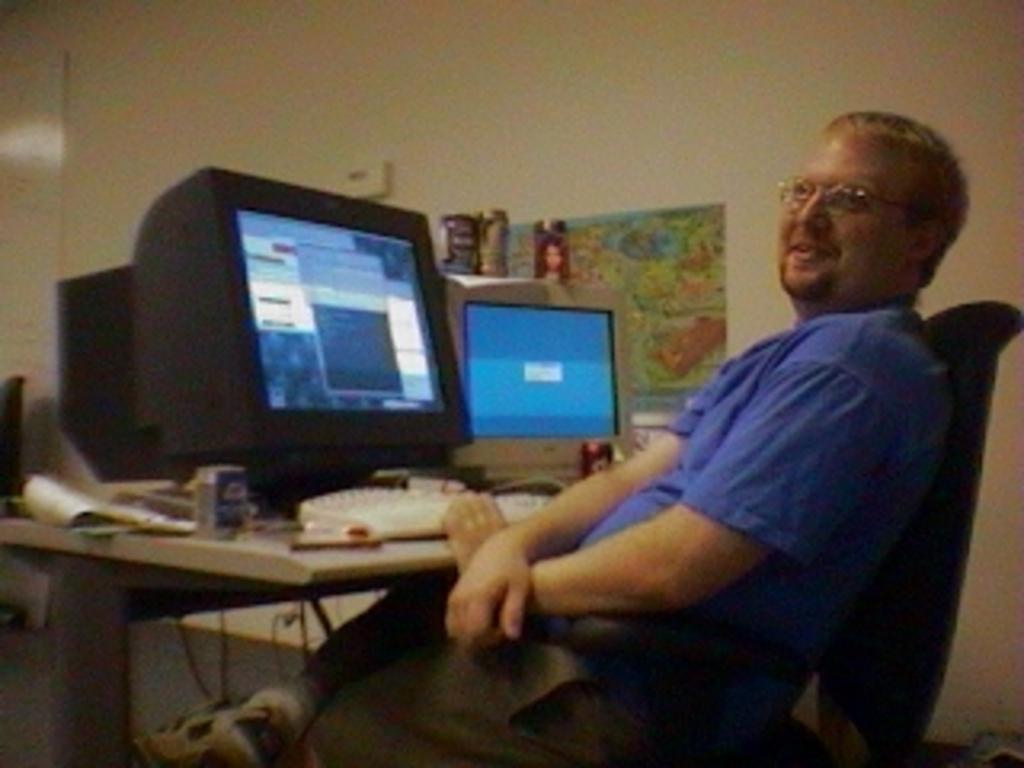What is the person in the image doing? The person is sitting on a chair in the image. What is in front of the person? There is a table in front of the person. What electronic device is on the table? A monitor is present on the table. What is used for typing on the monitor? A keyboard is on the table. What else is on the table besides the monitor and keyboard? There are papers on the table. What can be seen in the background of the image? There is a wall in the background of the image. What type of owl can be seen sitting on the person's shoulder in the image? There is no owl present in the image; the person is sitting alone on the chair. 